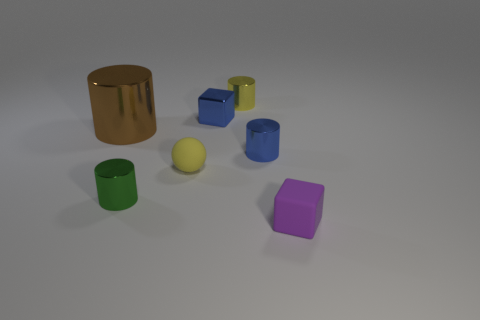Add 2 tiny brown cylinders. How many objects exist? 9 Add 1 small yellow matte spheres. How many small yellow matte spheres exist? 2 Subtract all brown cylinders. How many cylinders are left? 3 Subtract all large brown cylinders. How many cylinders are left? 3 Subtract 0 brown cubes. How many objects are left? 7 Subtract all balls. How many objects are left? 6 Subtract 2 cylinders. How many cylinders are left? 2 Subtract all blue cylinders. Subtract all gray blocks. How many cylinders are left? 3 Subtract all blue cubes. How many blue cylinders are left? 1 Subtract all tiny purple matte cubes. Subtract all yellow balls. How many objects are left? 5 